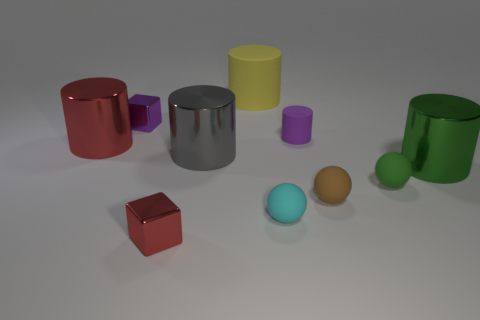There is a block that is the same color as the tiny cylinder; what is its size?
Offer a very short reply. Small. There is a small cube that is the same color as the small rubber cylinder; what material is it?
Your answer should be very brief. Metal. There is a purple cylinder; does it have the same size as the shiny object that is in front of the tiny green matte object?
Provide a short and direct response. Yes. How many things are either large cylinders that are on the left side of the small purple shiny block or small purple matte spheres?
Offer a very short reply. 1. There is a red object that is to the left of the tiny red object; what is its shape?
Offer a terse response. Cylinder. Is the number of red cylinders in front of the red metal cube the same as the number of green things behind the yellow object?
Make the answer very short. Yes. What is the color of the object that is right of the brown sphere and on the left side of the green cylinder?
Offer a terse response. Green. The large cylinder that is behind the large object that is on the left side of the large gray shiny thing is made of what material?
Give a very brief answer. Rubber. Is the size of the yellow object the same as the gray thing?
Offer a terse response. Yes. How many big objects are cyan cylinders or green things?
Your response must be concise. 1. 